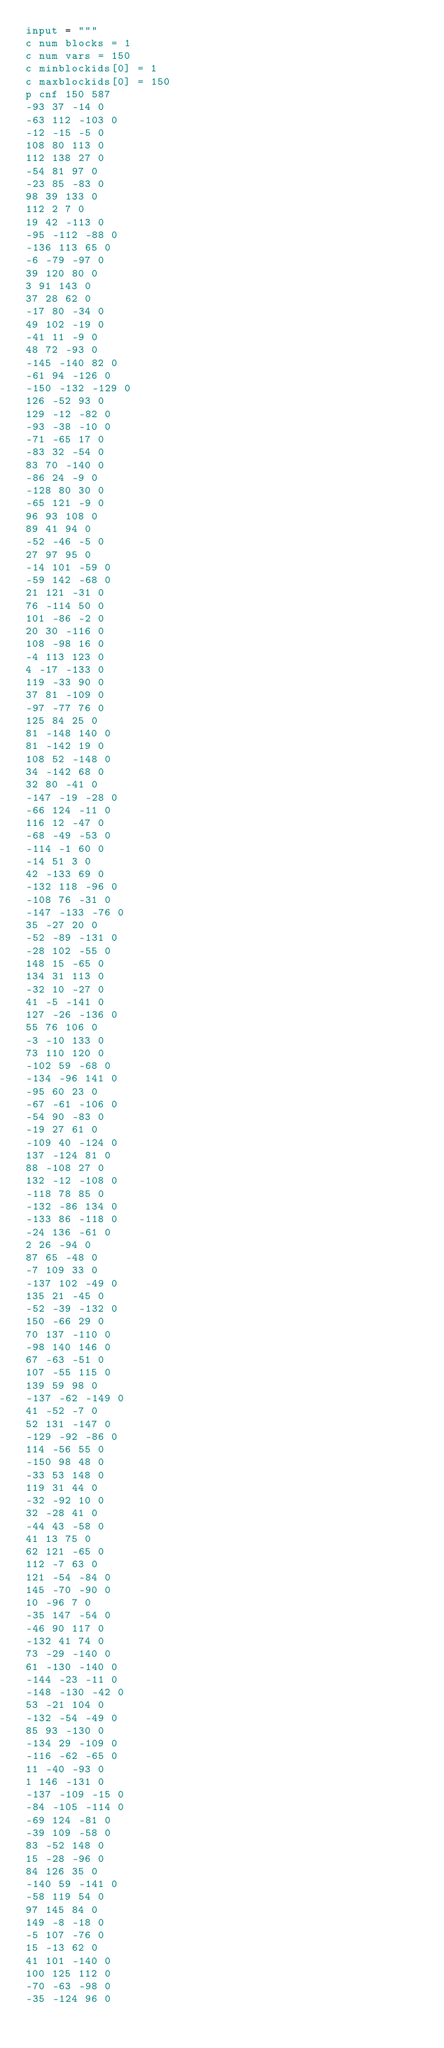<code> <loc_0><loc_0><loc_500><loc_500><_Python_>input = """
c num blocks = 1
c num vars = 150
c minblockids[0] = 1
c maxblockids[0] = 150
p cnf 150 587
-93 37 -14 0
-63 112 -103 0
-12 -15 -5 0
108 80 113 0
112 138 27 0
-54 81 97 0
-23 85 -83 0
98 39 133 0
112 2 7 0
19 42 -113 0
-95 -112 -88 0
-136 113 65 0
-6 -79 -97 0
39 120 80 0
3 91 143 0
37 28 62 0
-17 80 -34 0
49 102 -19 0
-41 11 -9 0
48 72 -93 0
-145 -140 82 0
-61 94 -126 0
-150 -132 -129 0
126 -52 93 0
129 -12 -82 0
-93 -38 -10 0
-71 -65 17 0
-83 32 -54 0
83 70 -140 0
-86 24 -9 0
-128 80 30 0
-65 121 -9 0
96 93 108 0
89 41 94 0
-52 -46 -5 0
27 97 95 0
-14 101 -59 0
-59 142 -68 0
21 121 -31 0
76 -114 50 0
101 -86 -2 0
20 30 -116 0
108 -98 16 0
-4 113 123 0
4 -17 -133 0
119 -33 90 0
37 81 -109 0
-97 -77 76 0
125 84 25 0
81 -148 140 0
81 -142 19 0
108 52 -148 0
34 -142 68 0
32 80 -41 0
-147 -19 -28 0
-66 124 -11 0
116 12 -47 0
-68 -49 -53 0
-114 -1 60 0
-14 51 3 0
42 -133 69 0
-132 118 -96 0
-108 76 -31 0
-147 -133 -76 0
35 -27 20 0
-52 -89 -131 0
-28 102 -55 0
148 15 -65 0
134 31 113 0
-32 10 -27 0
41 -5 -141 0
127 -26 -136 0
55 76 106 0
-3 -10 133 0
73 110 120 0
-102 59 -68 0
-134 -96 141 0
-95 60 23 0
-67 -61 -106 0
-54 90 -83 0
-19 27 61 0
-109 40 -124 0
137 -124 81 0
88 -108 27 0
132 -12 -108 0
-118 78 85 0
-132 -86 134 0
-133 86 -118 0
-24 136 -61 0
2 26 -94 0
87 65 -48 0
-7 109 33 0
-137 102 -49 0
135 21 -45 0
-52 -39 -132 0
150 -66 29 0
70 137 -110 0
-98 140 146 0
67 -63 -51 0
107 -55 115 0
139 59 98 0
-137 -62 -149 0
41 -52 -7 0
52 131 -147 0
-129 -92 -86 0
114 -56 55 0
-150 98 48 0
-33 53 148 0
119 31 44 0
-32 -92 10 0
32 -28 41 0
-44 43 -58 0
41 13 75 0
62 121 -65 0
112 -7 63 0
121 -54 -84 0
145 -70 -90 0
10 -96 7 0
-35 147 -54 0
-46 90 117 0
-132 41 74 0
73 -29 -140 0
61 -130 -140 0
-144 -23 -11 0
-148 -130 -42 0
53 -21 104 0
-132 -54 -49 0
85 93 -130 0
-134 29 -109 0
-116 -62 -65 0
11 -40 -93 0
1 146 -131 0
-137 -109 -15 0
-84 -105 -114 0
-69 124 -81 0
-39 109 -58 0
83 -52 148 0
15 -28 -96 0
84 126 35 0
-140 59 -141 0
-58 119 54 0
97 145 84 0
149 -8 -18 0
-5 107 -76 0
15 -13 62 0
41 101 -140 0
100 125 112 0
-70 -63 -98 0
-35 -124 96 0</code> 